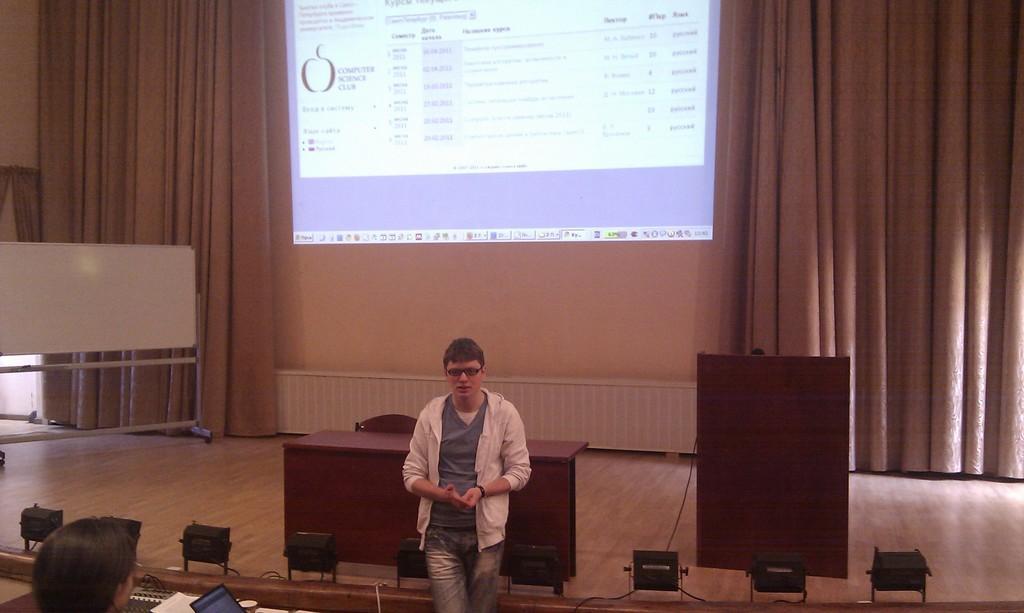Describe this image in one or two sentences. In this picture we can see two people, laptop, glass, table, podium, chair, board and some objects and a man wore a spectacle and standing and in the background we can see curtains, wall, screen. 